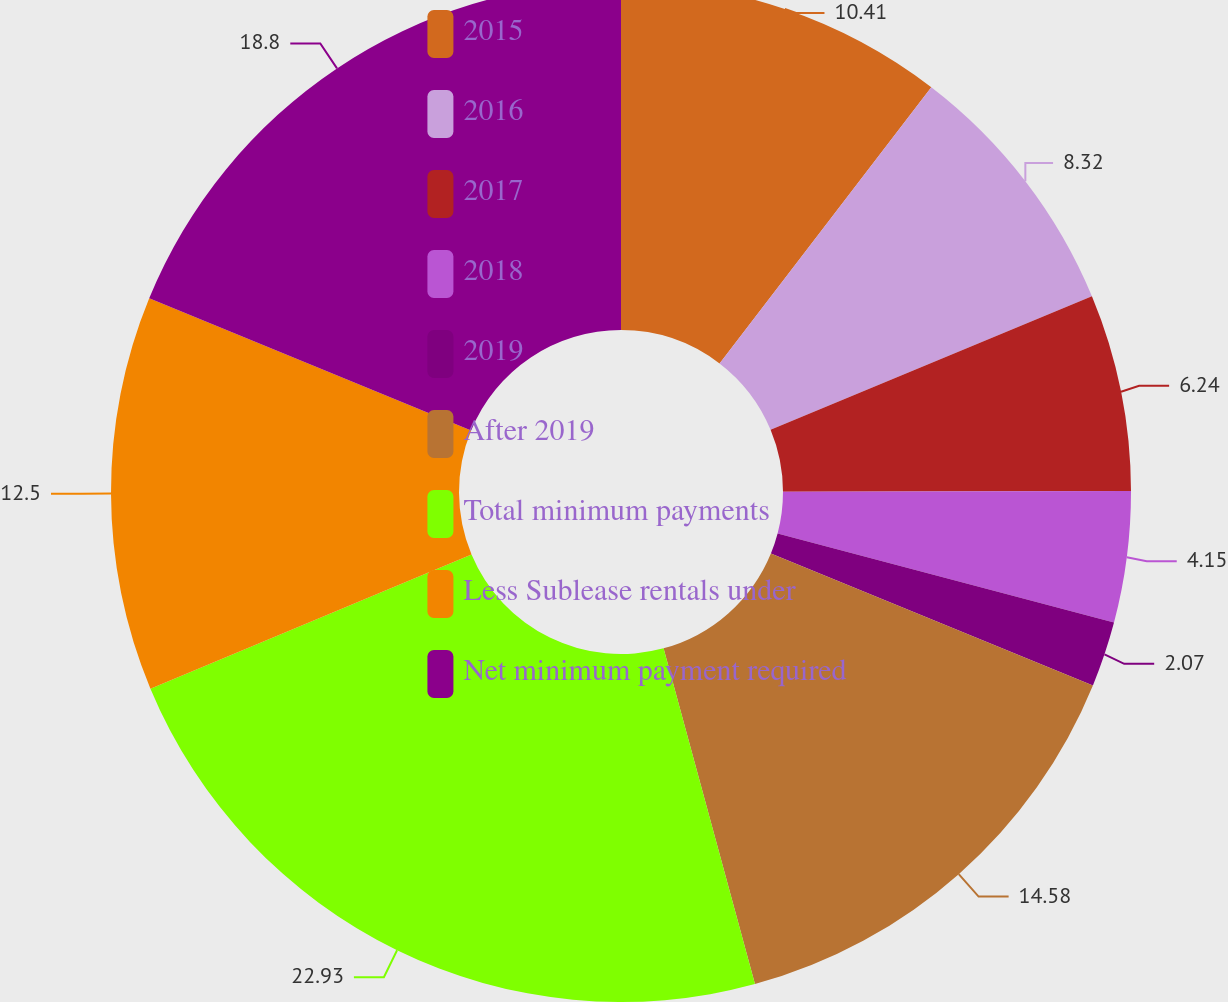<chart> <loc_0><loc_0><loc_500><loc_500><pie_chart><fcel>2015<fcel>2016<fcel>2017<fcel>2018<fcel>2019<fcel>After 2019<fcel>Total minimum payments<fcel>Less Sublease rentals under<fcel>Net minimum payment required<nl><fcel>10.41%<fcel>8.32%<fcel>6.24%<fcel>4.15%<fcel>2.07%<fcel>14.58%<fcel>22.93%<fcel>12.5%<fcel>18.8%<nl></chart> 